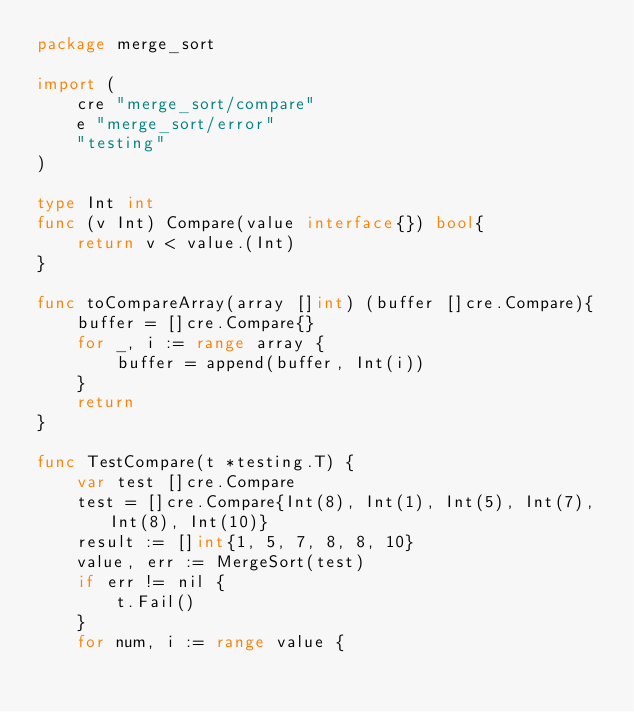Convert code to text. <code><loc_0><loc_0><loc_500><loc_500><_Go_>package merge_sort

import (
	cre "merge_sort/compare"
	e "merge_sort/error"
	"testing"
)

type Int int
func (v Int) Compare(value interface{}) bool{
	return v < value.(Int)
}

func toCompareArray(array []int) (buffer []cre.Compare){
	buffer = []cre.Compare{}
	for _, i := range array {
		buffer = append(buffer, Int(i))
	}
	return
}

func TestCompare(t *testing.T) {
	var test []cre.Compare
	test = []cre.Compare{Int(8), Int(1), Int(5), Int(7), Int(8), Int(10)}
	result := []int{1, 5, 7, 8, 8, 10}
	value, err := MergeSort(test)
	if err != nil {
		t.Fail()
	}
	for num, i := range value {</code> 